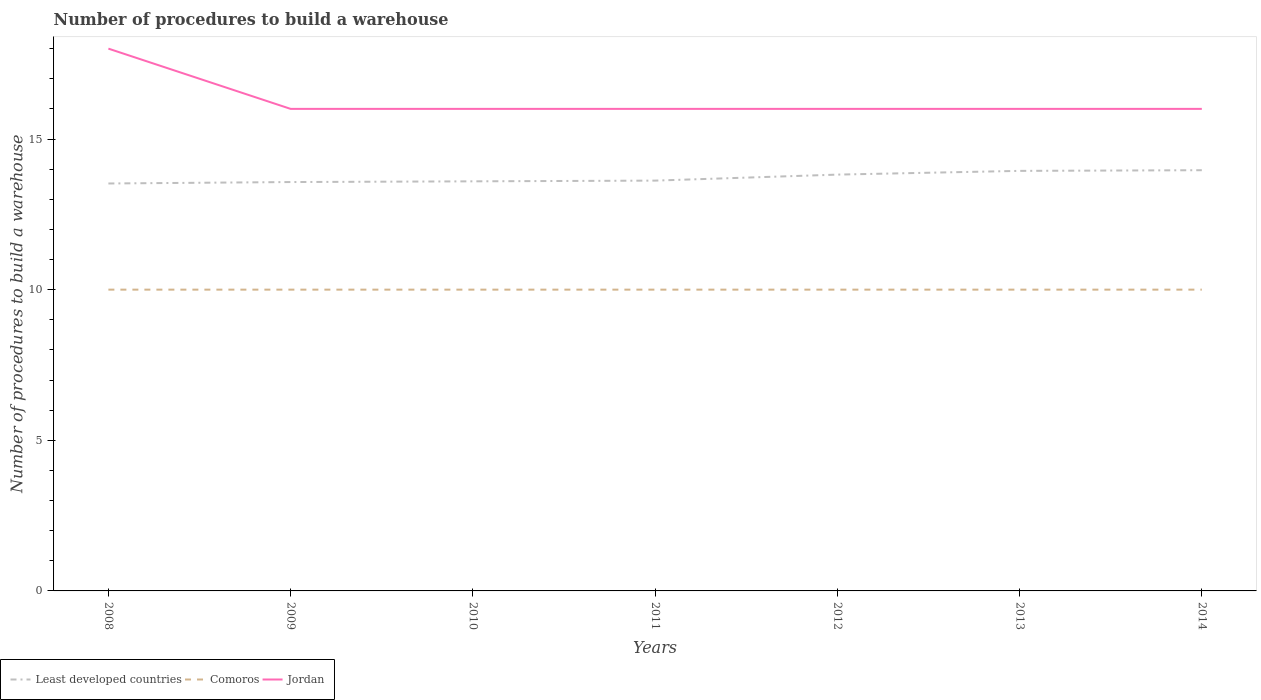Across all years, what is the maximum number of procedures to build a warehouse in in Least developed countries?
Offer a very short reply. 13.52. What is the total number of procedures to build a warehouse in in Jordan in the graph?
Make the answer very short. 0. What is the difference between the highest and the second highest number of procedures to build a warehouse in in Comoros?
Offer a very short reply. 0. Is the number of procedures to build a warehouse in in Comoros strictly greater than the number of procedures to build a warehouse in in Jordan over the years?
Your response must be concise. Yes. How many years are there in the graph?
Provide a short and direct response. 7. What is the difference between two consecutive major ticks on the Y-axis?
Provide a short and direct response. 5. Does the graph contain any zero values?
Give a very brief answer. No. Does the graph contain grids?
Make the answer very short. No. How many legend labels are there?
Provide a short and direct response. 3. How are the legend labels stacked?
Make the answer very short. Horizontal. What is the title of the graph?
Provide a succinct answer. Number of procedures to build a warehouse. What is the label or title of the Y-axis?
Provide a short and direct response. Number of procedures to build a warehouse. What is the Number of procedures to build a warehouse in Least developed countries in 2008?
Your answer should be compact. 13.52. What is the Number of procedures to build a warehouse in Least developed countries in 2009?
Your answer should be compact. 13.57. What is the Number of procedures to build a warehouse in Comoros in 2009?
Provide a short and direct response. 10. What is the Number of procedures to build a warehouse of Least developed countries in 2010?
Offer a terse response. 13.6. What is the Number of procedures to build a warehouse in Comoros in 2010?
Provide a succinct answer. 10. What is the Number of procedures to build a warehouse in Jordan in 2010?
Your answer should be compact. 16. What is the Number of procedures to build a warehouse of Least developed countries in 2011?
Keep it short and to the point. 13.62. What is the Number of procedures to build a warehouse of Comoros in 2011?
Your response must be concise. 10. What is the Number of procedures to build a warehouse in Least developed countries in 2012?
Provide a succinct answer. 13.82. What is the Number of procedures to build a warehouse of Comoros in 2012?
Your response must be concise. 10. What is the Number of procedures to build a warehouse in Jordan in 2012?
Offer a very short reply. 16. What is the Number of procedures to build a warehouse of Least developed countries in 2013?
Your answer should be compact. 13.94. What is the Number of procedures to build a warehouse of Comoros in 2013?
Ensure brevity in your answer.  10. What is the Number of procedures to build a warehouse in Least developed countries in 2014?
Give a very brief answer. 13.96. What is the Number of procedures to build a warehouse of Jordan in 2014?
Your answer should be very brief. 16. Across all years, what is the maximum Number of procedures to build a warehouse of Least developed countries?
Provide a succinct answer. 13.96. Across all years, what is the maximum Number of procedures to build a warehouse of Jordan?
Your answer should be very brief. 18. Across all years, what is the minimum Number of procedures to build a warehouse of Least developed countries?
Your answer should be very brief. 13.52. Across all years, what is the minimum Number of procedures to build a warehouse of Comoros?
Provide a succinct answer. 10. Across all years, what is the minimum Number of procedures to build a warehouse of Jordan?
Make the answer very short. 16. What is the total Number of procedures to build a warehouse of Least developed countries in the graph?
Provide a succinct answer. 96.03. What is the total Number of procedures to build a warehouse in Comoros in the graph?
Keep it short and to the point. 70. What is the total Number of procedures to build a warehouse of Jordan in the graph?
Offer a terse response. 114. What is the difference between the Number of procedures to build a warehouse in Least developed countries in 2008 and that in 2009?
Ensure brevity in your answer.  -0.05. What is the difference between the Number of procedures to build a warehouse of Least developed countries in 2008 and that in 2010?
Your answer should be very brief. -0.07. What is the difference between the Number of procedures to build a warehouse of Least developed countries in 2008 and that in 2011?
Make the answer very short. -0.1. What is the difference between the Number of procedures to build a warehouse of Comoros in 2008 and that in 2011?
Offer a very short reply. 0. What is the difference between the Number of procedures to build a warehouse of Least developed countries in 2008 and that in 2012?
Your response must be concise. -0.29. What is the difference between the Number of procedures to build a warehouse of Jordan in 2008 and that in 2012?
Your answer should be very brief. 2. What is the difference between the Number of procedures to build a warehouse in Least developed countries in 2008 and that in 2013?
Your response must be concise. -0.42. What is the difference between the Number of procedures to build a warehouse of Jordan in 2008 and that in 2013?
Provide a succinct answer. 2. What is the difference between the Number of procedures to build a warehouse of Least developed countries in 2008 and that in 2014?
Make the answer very short. -0.44. What is the difference between the Number of procedures to build a warehouse in Comoros in 2008 and that in 2014?
Offer a very short reply. 0. What is the difference between the Number of procedures to build a warehouse in Least developed countries in 2009 and that in 2010?
Keep it short and to the point. -0.02. What is the difference between the Number of procedures to build a warehouse in Least developed countries in 2009 and that in 2011?
Your answer should be compact. -0.05. What is the difference between the Number of procedures to build a warehouse of Least developed countries in 2009 and that in 2012?
Ensure brevity in your answer.  -0.25. What is the difference between the Number of procedures to build a warehouse of Comoros in 2009 and that in 2012?
Keep it short and to the point. 0. What is the difference between the Number of procedures to build a warehouse in Jordan in 2009 and that in 2012?
Ensure brevity in your answer.  0. What is the difference between the Number of procedures to build a warehouse in Least developed countries in 2009 and that in 2013?
Provide a short and direct response. -0.37. What is the difference between the Number of procedures to build a warehouse of Jordan in 2009 and that in 2013?
Provide a succinct answer. 0. What is the difference between the Number of procedures to build a warehouse in Least developed countries in 2009 and that in 2014?
Your answer should be very brief. -0.39. What is the difference between the Number of procedures to build a warehouse of Comoros in 2009 and that in 2014?
Provide a succinct answer. 0. What is the difference between the Number of procedures to build a warehouse in Jordan in 2009 and that in 2014?
Offer a very short reply. 0. What is the difference between the Number of procedures to build a warehouse in Least developed countries in 2010 and that in 2011?
Provide a short and direct response. -0.02. What is the difference between the Number of procedures to build a warehouse of Comoros in 2010 and that in 2011?
Ensure brevity in your answer.  0. What is the difference between the Number of procedures to build a warehouse in Jordan in 2010 and that in 2011?
Offer a very short reply. 0. What is the difference between the Number of procedures to build a warehouse of Least developed countries in 2010 and that in 2012?
Keep it short and to the point. -0.22. What is the difference between the Number of procedures to build a warehouse in Comoros in 2010 and that in 2012?
Ensure brevity in your answer.  0. What is the difference between the Number of procedures to build a warehouse of Jordan in 2010 and that in 2012?
Offer a very short reply. 0. What is the difference between the Number of procedures to build a warehouse of Least developed countries in 2010 and that in 2013?
Make the answer very short. -0.35. What is the difference between the Number of procedures to build a warehouse in Comoros in 2010 and that in 2013?
Keep it short and to the point. 0. What is the difference between the Number of procedures to build a warehouse of Least developed countries in 2010 and that in 2014?
Give a very brief answer. -0.37. What is the difference between the Number of procedures to build a warehouse of Least developed countries in 2011 and that in 2012?
Your response must be concise. -0.2. What is the difference between the Number of procedures to build a warehouse of Least developed countries in 2011 and that in 2013?
Make the answer very short. -0.32. What is the difference between the Number of procedures to build a warehouse of Least developed countries in 2011 and that in 2014?
Your answer should be compact. -0.35. What is the difference between the Number of procedures to build a warehouse of Jordan in 2011 and that in 2014?
Ensure brevity in your answer.  0. What is the difference between the Number of procedures to build a warehouse of Least developed countries in 2012 and that in 2013?
Provide a succinct answer. -0.12. What is the difference between the Number of procedures to build a warehouse in Comoros in 2012 and that in 2013?
Keep it short and to the point. 0. What is the difference between the Number of procedures to build a warehouse in Least developed countries in 2012 and that in 2014?
Give a very brief answer. -0.15. What is the difference between the Number of procedures to build a warehouse in Comoros in 2012 and that in 2014?
Make the answer very short. 0. What is the difference between the Number of procedures to build a warehouse in Least developed countries in 2013 and that in 2014?
Offer a terse response. -0.02. What is the difference between the Number of procedures to build a warehouse of Least developed countries in 2008 and the Number of procedures to build a warehouse of Comoros in 2009?
Your answer should be very brief. 3.52. What is the difference between the Number of procedures to build a warehouse of Least developed countries in 2008 and the Number of procedures to build a warehouse of Jordan in 2009?
Provide a succinct answer. -2.48. What is the difference between the Number of procedures to build a warehouse of Least developed countries in 2008 and the Number of procedures to build a warehouse of Comoros in 2010?
Provide a short and direct response. 3.52. What is the difference between the Number of procedures to build a warehouse of Least developed countries in 2008 and the Number of procedures to build a warehouse of Jordan in 2010?
Offer a very short reply. -2.48. What is the difference between the Number of procedures to build a warehouse of Comoros in 2008 and the Number of procedures to build a warehouse of Jordan in 2010?
Give a very brief answer. -6. What is the difference between the Number of procedures to build a warehouse of Least developed countries in 2008 and the Number of procedures to build a warehouse of Comoros in 2011?
Provide a short and direct response. 3.52. What is the difference between the Number of procedures to build a warehouse of Least developed countries in 2008 and the Number of procedures to build a warehouse of Jordan in 2011?
Your answer should be very brief. -2.48. What is the difference between the Number of procedures to build a warehouse of Least developed countries in 2008 and the Number of procedures to build a warehouse of Comoros in 2012?
Your response must be concise. 3.52. What is the difference between the Number of procedures to build a warehouse in Least developed countries in 2008 and the Number of procedures to build a warehouse in Jordan in 2012?
Ensure brevity in your answer.  -2.48. What is the difference between the Number of procedures to build a warehouse of Least developed countries in 2008 and the Number of procedures to build a warehouse of Comoros in 2013?
Provide a succinct answer. 3.52. What is the difference between the Number of procedures to build a warehouse in Least developed countries in 2008 and the Number of procedures to build a warehouse in Jordan in 2013?
Provide a succinct answer. -2.48. What is the difference between the Number of procedures to build a warehouse in Least developed countries in 2008 and the Number of procedures to build a warehouse in Comoros in 2014?
Your answer should be very brief. 3.52. What is the difference between the Number of procedures to build a warehouse of Least developed countries in 2008 and the Number of procedures to build a warehouse of Jordan in 2014?
Give a very brief answer. -2.48. What is the difference between the Number of procedures to build a warehouse of Comoros in 2008 and the Number of procedures to build a warehouse of Jordan in 2014?
Make the answer very short. -6. What is the difference between the Number of procedures to build a warehouse in Least developed countries in 2009 and the Number of procedures to build a warehouse in Comoros in 2010?
Give a very brief answer. 3.57. What is the difference between the Number of procedures to build a warehouse of Least developed countries in 2009 and the Number of procedures to build a warehouse of Jordan in 2010?
Provide a short and direct response. -2.43. What is the difference between the Number of procedures to build a warehouse in Comoros in 2009 and the Number of procedures to build a warehouse in Jordan in 2010?
Ensure brevity in your answer.  -6. What is the difference between the Number of procedures to build a warehouse of Least developed countries in 2009 and the Number of procedures to build a warehouse of Comoros in 2011?
Keep it short and to the point. 3.57. What is the difference between the Number of procedures to build a warehouse of Least developed countries in 2009 and the Number of procedures to build a warehouse of Jordan in 2011?
Offer a terse response. -2.43. What is the difference between the Number of procedures to build a warehouse of Comoros in 2009 and the Number of procedures to build a warehouse of Jordan in 2011?
Give a very brief answer. -6. What is the difference between the Number of procedures to build a warehouse in Least developed countries in 2009 and the Number of procedures to build a warehouse in Comoros in 2012?
Your answer should be compact. 3.57. What is the difference between the Number of procedures to build a warehouse of Least developed countries in 2009 and the Number of procedures to build a warehouse of Jordan in 2012?
Ensure brevity in your answer.  -2.43. What is the difference between the Number of procedures to build a warehouse of Comoros in 2009 and the Number of procedures to build a warehouse of Jordan in 2012?
Your response must be concise. -6. What is the difference between the Number of procedures to build a warehouse in Least developed countries in 2009 and the Number of procedures to build a warehouse in Comoros in 2013?
Provide a short and direct response. 3.57. What is the difference between the Number of procedures to build a warehouse in Least developed countries in 2009 and the Number of procedures to build a warehouse in Jordan in 2013?
Give a very brief answer. -2.43. What is the difference between the Number of procedures to build a warehouse of Comoros in 2009 and the Number of procedures to build a warehouse of Jordan in 2013?
Make the answer very short. -6. What is the difference between the Number of procedures to build a warehouse of Least developed countries in 2009 and the Number of procedures to build a warehouse of Comoros in 2014?
Keep it short and to the point. 3.57. What is the difference between the Number of procedures to build a warehouse in Least developed countries in 2009 and the Number of procedures to build a warehouse in Jordan in 2014?
Provide a succinct answer. -2.43. What is the difference between the Number of procedures to build a warehouse of Least developed countries in 2010 and the Number of procedures to build a warehouse of Comoros in 2011?
Ensure brevity in your answer.  3.6. What is the difference between the Number of procedures to build a warehouse of Least developed countries in 2010 and the Number of procedures to build a warehouse of Jordan in 2011?
Your answer should be very brief. -2.4. What is the difference between the Number of procedures to build a warehouse in Comoros in 2010 and the Number of procedures to build a warehouse in Jordan in 2011?
Your response must be concise. -6. What is the difference between the Number of procedures to build a warehouse in Least developed countries in 2010 and the Number of procedures to build a warehouse in Comoros in 2012?
Your answer should be compact. 3.6. What is the difference between the Number of procedures to build a warehouse in Least developed countries in 2010 and the Number of procedures to build a warehouse in Jordan in 2012?
Your answer should be compact. -2.4. What is the difference between the Number of procedures to build a warehouse of Least developed countries in 2010 and the Number of procedures to build a warehouse of Comoros in 2013?
Ensure brevity in your answer.  3.6. What is the difference between the Number of procedures to build a warehouse of Least developed countries in 2010 and the Number of procedures to build a warehouse of Jordan in 2013?
Keep it short and to the point. -2.4. What is the difference between the Number of procedures to build a warehouse of Least developed countries in 2010 and the Number of procedures to build a warehouse of Comoros in 2014?
Make the answer very short. 3.6. What is the difference between the Number of procedures to build a warehouse in Least developed countries in 2010 and the Number of procedures to build a warehouse in Jordan in 2014?
Ensure brevity in your answer.  -2.4. What is the difference between the Number of procedures to build a warehouse of Comoros in 2010 and the Number of procedures to build a warehouse of Jordan in 2014?
Make the answer very short. -6. What is the difference between the Number of procedures to build a warehouse in Least developed countries in 2011 and the Number of procedures to build a warehouse in Comoros in 2012?
Your response must be concise. 3.62. What is the difference between the Number of procedures to build a warehouse in Least developed countries in 2011 and the Number of procedures to build a warehouse in Jordan in 2012?
Give a very brief answer. -2.38. What is the difference between the Number of procedures to build a warehouse of Comoros in 2011 and the Number of procedures to build a warehouse of Jordan in 2012?
Offer a terse response. -6. What is the difference between the Number of procedures to build a warehouse in Least developed countries in 2011 and the Number of procedures to build a warehouse in Comoros in 2013?
Provide a succinct answer. 3.62. What is the difference between the Number of procedures to build a warehouse in Least developed countries in 2011 and the Number of procedures to build a warehouse in Jordan in 2013?
Ensure brevity in your answer.  -2.38. What is the difference between the Number of procedures to build a warehouse of Least developed countries in 2011 and the Number of procedures to build a warehouse of Comoros in 2014?
Your answer should be compact. 3.62. What is the difference between the Number of procedures to build a warehouse of Least developed countries in 2011 and the Number of procedures to build a warehouse of Jordan in 2014?
Give a very brief answer. -2.38. What is the difference between the Number of procedures to build a warehouse in Least developed countries in 2012 and the Number of procedures to build a warehouse in Comoros in 2013?
Provide a succinct answer. 3.82. What is the difference between the Number of procedures to build a warehouse in Least developed countries in 2012 and the Number of procedures to build a warehouse in Jordan in 2013?
Give a very brief answer. -2.18. What is the difference between the Number of procedures to build a warehouse of Least developed countries in 2012 and the Number of procedures to build a warehouse of Comoros in 2014?
Provide a short and direct response. 3.82. What is the difference between the Number of procedures to build a warehouse of Least developed countries in 2012 and the Number of procedures to build a warehouse of Jordan in 2014?
Ensure brevity in your answer.  -2.18. What is the difference between the Number of procedures to build a warehouse of Comoros in 2012 and the Number of procedures to build a warehouse of Jordan in 2014?
Ensure brevity in your answer.  -6. What is the difference between the Number of procedures to build a warehouse of Least developed countries in 2013 and the Number of procedures to build a warehouse of Comoros in 2014?
Your answer should be compact. 3.94. What is the difference between the Number of procedures to build a warehouse in Least developed countries in 2013 and the Number of procedures to build a warehouse in Jordan in 2014?
Your response must be concise. -2.06. What is the difference between the Number of procedures to build a warehouse of Comoros in 2013 and the Number of procedures to build a warehouse of Jordan in 2014?
Ensure brevity in your answer.  -6. What is the average Number of procedures to build a warehouse of Least developed countries per year?
Ensure brevity in your answer.  13.72. What is the average Number of procedures to build a warehouse of Jordan per year?
Provide a succinct answer. 16.29. In the year 2008, what is the difference between the Number of procedures to build a warehouse in Least developed countries and Number of procedures to build a warehouse in Comoros?
Your answer should be very brief. 3.52. In the year 2008, what is the difference between the Number of procedures to build a warehouse in Least developed countries and Number of procedures to build a warehouse in Jordan?
Offer a very short reply. -4.48. In the year 2008, what is the difference between the Number of procedures to build a warehouse of Comoros and Number of procedures to build a warehouse of Jordan?
Provide a short and direct response. -8. In the year 2009, what is the difference between the Number of procedures to build a warehouse of Least developed countries and Number of procedures to build a warehouse of Comoros?
Your answer should be very brief. 3.57. In the year 2009, what is the difference between the Number of procedures to build a warehouse in Least developed countries and Number of procedures to build a warehouse in Jordan?
Ensure brevity in your answer.  -2.43. In the year 2010, what is the difference between the Number of procedures to build a warehouse in Least developed countries and Number of procedures to build a warehouse in Comoros?
Offer a terse response. 3.6. In the year 2010, what is the difference between the Number of procedures to build a warehouse in Least developed countries and Number of procedures to build a warehouse in Jordan?
Offer a terse response. -2.4. In the year 2010, what is the difference between the Number of procedures to build a warehouse of Comoros and Number of procedures to build a warehouse of Jordan?
Your answer should be very brief. -6. In the year 2011, what is the difference between the Number of procedures to build a warehouse in Least developed countries and Number of procedures to build a warehouse in Comoros?
Provide a short and direct response. 3.62. In the year 2011, what is the difference between the Number of procedures to build a warehouse of Least developed countries and Number of procedures to build a warehouse of Jordan?
Your response must be concise. -2.38. In the year 2011, what is the difference between the Number of procedures to build a warehouse of Comoros and Number of procedures to build a warehouse of Jordan?
Your answer should be compact. -6. In the year 2012, what is the difference between the Number of procedures to build a warehouse in Least developed countries and Number of procedures to build a warehouse in Comoros?
Your answer should be very brief. 3.82. In the year 2012, what is the difference between the Number of procedures to build a warehouse in Least developed countries and Number of procedures to build a warehouse in Jordan?
Give a very brief answer. -2.18. In the year 2012, what is the difference between the Number of procedures to build a warehouse in Comoros and Number of procedures to build a warehouse in Jordan?
Provide a short and direct response. -6. In the year 2013, what is the difference between the Number of procedures to build a warehouse of Least developed countries and Number of procedures to build a warehouse of Comoros?
Make the answer very short. 3.94. In the year 2013, what is the difference between the Number of procedures to build a warehouse in Least developed countries and Number of procedures to build a warehouse in Jordan?
Give a very brief answer. -2.06. In the year 2013, what is the difference between the Number of procedures to build a warehouse in Comoros and Number of procedures to build a warehouse in Jordan?
Your answer should be very brief. -6. In the year 2014, what is the difference between the Number of procedures to build a warehouse in Least developed countries and Number of procedures to build a warehouse in Comoros?
Provide a short and direct response. 3.96. In the year 2014, what is the difference between the Number of procedures to build a warehouse in Least developed countries and Number of procedures to build a warehouse in Jordan?
Offer a very short reply. -2.04. What is the ratio of the Number of procedures to build a warehouse in Comoros in 2008 to that in 2009?
Offer a terse response. 1. What is the ratio of the Number of procedures to build a warehouse of Least developed countries in 2008 to that in 2010?
Your answer should be very brief. 0.99. What is the ratio of the Number of procedures to build a warehouse in Jordan in 2008 to that in 2010?
Offer a terse response. 1.12. What is the ratio of the Number of procedures to build a warehouse of Comoros in 2008 to that in 2011?
Your answer should be very brief. 1. What is the ratio of the Number of procedures to build a warehouse in Least developed countries in 2008 to that in 2012?
Your response must be concise. 0.98. What is the ratio of the Number of procedures to build a warehouse in Comoros in 2008 to that in 2012?
Keep it short and to the point. 1. What is the ratio of the Number of procedures to build a warehouse in Jordan in 2008 to that in 2012?
Your response must be concise. 1.12. What is the ratio of the Number of procedures to build a warehouse of Least developed countries in 2008 to that in 2014?
Provide a succinct answer. 0.97. What is the ratio of the Number of procedures to build a warehouse in Comoros in 2008 to that in 2014?
Give a very brief answer. 1. What is the ratio of the Number of procedures to build a warehouse of Jordan in 2008 to that in 2014?
Your answer should be very brief. 1.12. What is the ratio of the Number of procedures to build a warehouse of Comoros in 2009 to that in 2010?
Your response must be concise. 1. What is the ratio of the Number of procedures to build a warehouse in Jordan in 2009 to that in 2010?
Your answer should be compact. 1. What is the ratio of the Number of procedures to build a warehouse of Least developed countries in 2009 to that in 2011?
Make the answer very short. 1. What is the ratio of the Number of procedures to build a warehouse of Least developed countries in 2009 to that in 2012?
Make the answer very short. 0.98. What is the ratio of the Number of procedures to build a warehouse in Comoros in 2009 to that in 2012?
Keep it short and to the point. 1. What is the ratio of the Number of procedures to build a warehouse of Jordan in 2009 to that in 2012?
Keep it short and to the point. 1. What is the ratio of the Number of procedures to build a warehouse of Least developed countries in 2009 to that in 2013?
Offer a terse response. 0.97. What is the ratio of the Number of procedures to build a warehouse of Jordan in 2009 to that in 2013?
Offer a terse response. 1. What is the ratio of the Number of procedures to build a warehouse of Least developed countries in 2009 to that in 2014?
Provide a succinct answer. 0.97. What is the ratio of the Number of procedures to build a warehouse in Jordan in 2009 to that in 2014?
Keep it short and to the point. 1. What is the ratio of the Number of procedures to build a warehouse in Least developed countries in 2010 to that in 2011?
Keep it short and to the point. 1. What is the ratio of the Number of procedures to build a warehouse in Comoros in 2010 to that in 2011?
Keep it short and to the point. 1. What is the ratio of the Number of procedures to build a warehouse in Jordan in 2010 to that in 2011?
Provide a short and direct response. 1. What is the ratio of the Number of procedures to build a warehouse of Least developed countries in 2010 to that in 2012?
Offer a terse response. 0.98. What is the ratio of the Number of procedures to build a warehouse in Comoros in 2010 to that in 2012?
Keep it short and to the point. 1. What is the ratio of the Number of procedures to build a warehouse of Jordan in 2010 to that in 2012?
Provide a succinct answer. 1. What is the ratio of the Number of procedures to build a warehouse of Least developed countries in 2010 to that in 2013?
Offer a terse response. 0.98. What is the ratio of the Number of procedures to build a warehouse of Jordan in 2010 to that in 2013?
Your answer should be very brief. 1. What is the ratio of the Number of procedures to build a warehouse of Least developed countries in 2010 to that in 2014?
Provide a short and direct response. 0.97. What is the ratio of the Number of procedures to build a warehouse of Comoros in 2010 to that in 2014?
Offer a very short reply. 1. What is the ratio of the Number of procedures to build a warehouse of Least developed countries in 2011 to that in 2012?
Give a very brief answer. 0.99. What is the ratio of the Number of procedures to build a warehouse of Jordan in 2011 to that in 2012?
Offer a terse response. 1. What is the ratio of the Number of procedures to build a warehouse in Least developed countries in 2011 to that in 2013?
Your answer should be very brief. 0.98. What is the ratio of the Number of procedures to build a warehouse in Jordan in 2011 to that in 2013?
Keep it short and to the point. 1. What is the ratio of the Number of procedures to build a warehouse in Least developed countries in 2011 to that in 2014?
Provide a short and direct response. 0.98. What is the ratio of the Number of procedures to build a warehouse in Jordan in 2011 to that in 2014?
Offer a very short reply. 1. What is the ratio of the Number of procedures to build a warehouse of Comoros in 2012 to that in 2013?
Provide a short and direct response. 1. What is the ratio of the Number of procedures to build a warehouse of Jordan in 2012 to that in 2013?
Keep it short and to the point. 1. What is the ratio of the Number of procedures to build a warehouse of Jordan in 2012 to that in 2014?
Your answer should be very brief. 1. What is the difference between the highest and the second highest Number of procedures to build a warehouse of Least developed countries?
Make the answer very short. 0.02. What is the difference between the highest and the second highest Number of procedures to build a warehouse in Comoros?
Your response must be concise. 0. What is the difference between the highest and the second highest Number of procedures to build a warehouse of Jordan?
Offer a terse response. 2. What is the difference between the highest and the lowest Number of procedures to build a warehouse of Least developed countries?
Ensure brevity in your answer.  0.44. What is the difference between the highest and the lowest Number of procedures to build a warehouse in Comoros?
Ensure brevity in your answer.  0. What is the difference between the highest and the lowest Number of procedures to build a warehouse of Jordan?
Make the answer very short. 2. 